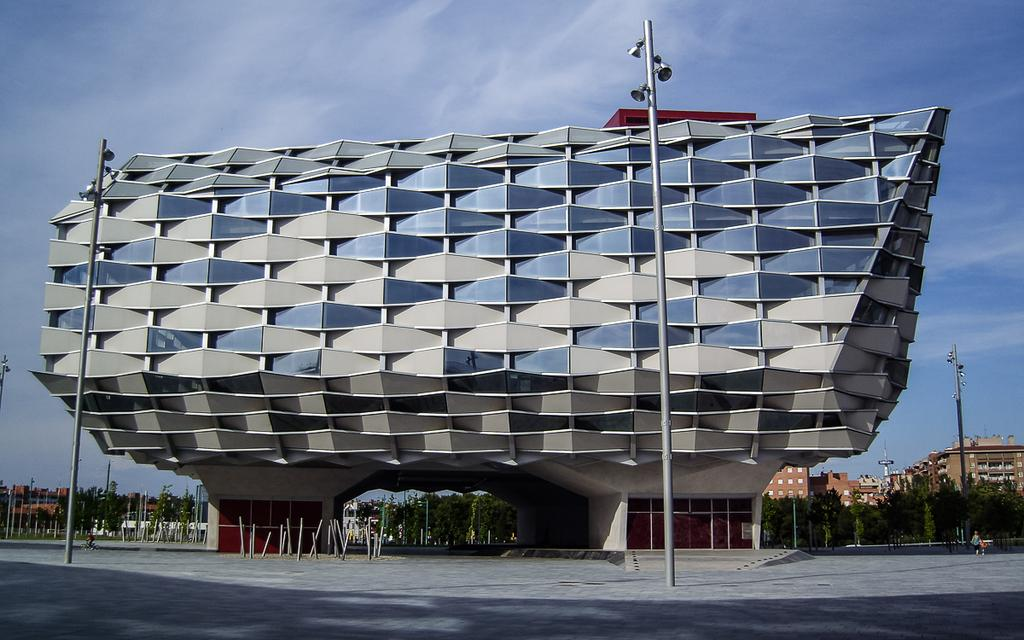What type of structure is the main subject in the image? There is a building with different shapes in the image. Can you describe the other structures visible in the background? There are other buildings visible in the background of the image. What type of tin can be seen being stretched by a rabbit in the image? There is no tin or rabbit present in the image. 